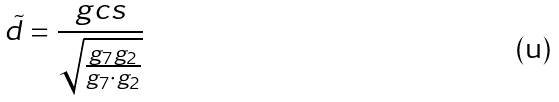Convert formula to latex. <formula><loc_0><loc_0><loc_500><loc_500>\tilde { d } = \frac { g c s } { \sqrt { \frac { g _ { 7 } g _ { 2 } } { g _ { 7 } \cdot g _ { 2 } } } }</formula> 